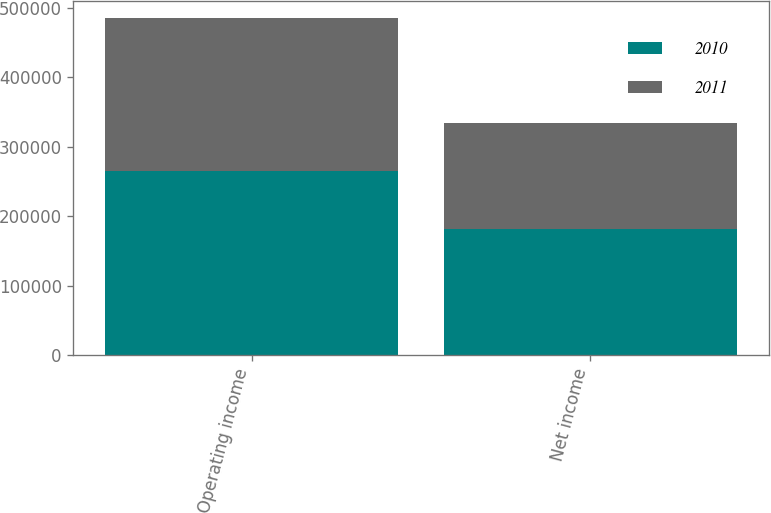Convert chart. <chart><loc_0><loc_0><loc_500><loc_500><stacked_bar_chart><ecel><fcel>Operating income<fcel>Net income<nl><fcel>2010<fcel>265559<fcel>180675<nl><fcel>2011<fcel>219268<fcel>153132<nl></chart> 